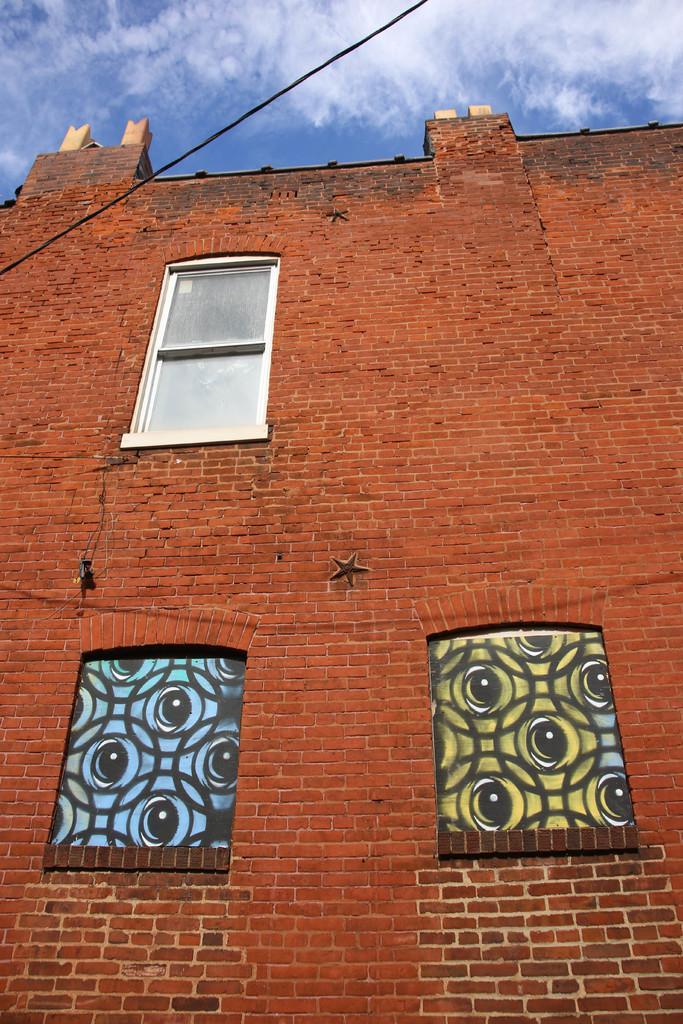Describe this image in one or two sentences. This image is taken outdoors. At the top of the image there is a sky with walls. In the middle of the image there is a building with a wall and windows. 